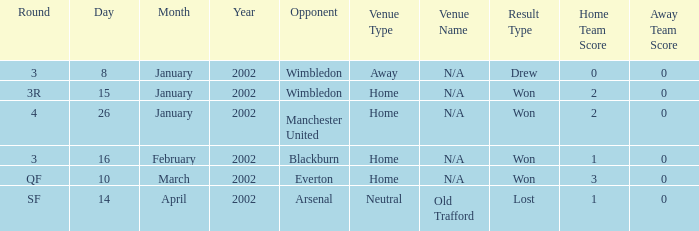What is the Round with a Opponent with blackburn? 3.0. 